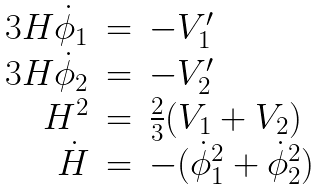Convert formula to latex. <formula><loc_0><loc_0><loc_500><loc_500>\begin{array} { r c l } 3 H \dot { \phi } _ { 1 } & = & - V _ { 1 } ^ { \prime } \\ 3 H \dot { \phi } _ { 2 } & = & - V _ { 2 } ^ { \prime } \\ H ^ { 2 } & = & \frac { 2 } { 3 } ( V _ { 1 } + V _ { 2 } ) \\ \dot { H } & = & - ( \dot { \phi } _ { 1 } ^ { 2 } + \dot { \phi } _ { 2 } ^ { 2 } ) \end{array}</formula> 